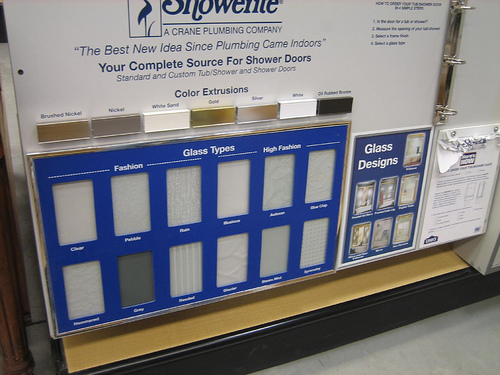<image>
Is there a writing above the sample? Yes. The writing is positioned above the sample in the vertical space, higher up in the scene. Where is the glass in relation to the ground? Is it on the ground? No. The glass is not positioned on the ground. They may be near each other, but the glass is not supported by or resting on top of the ground. 